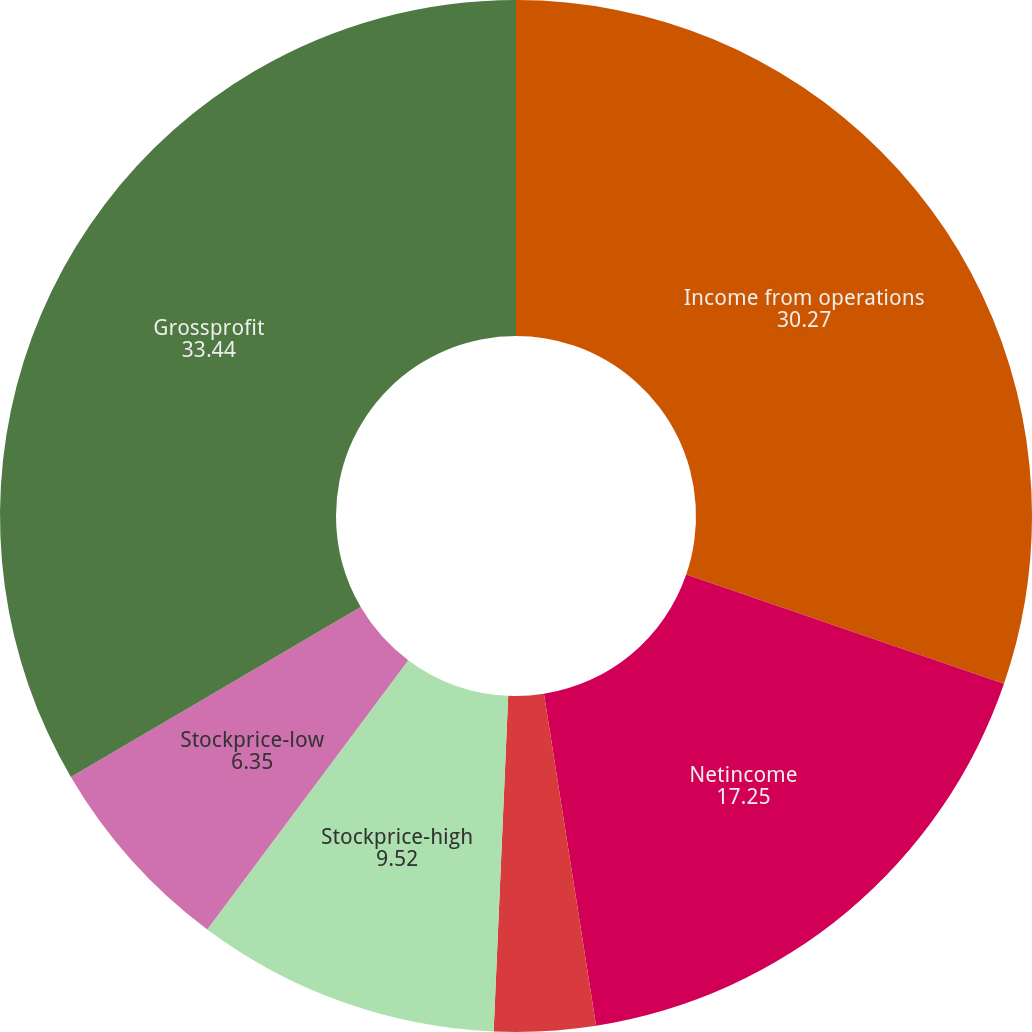Convert chart. <chart><loc_0><loc_0><loc_500><loc_500><pie_chart><fcel>Income from operations<fcel>Netincome<fcel>Basicearningsper share<fcel>Diluted earnings per share<fcel>Stockprice-high<fcel>Stockprice-low<fcel>Grossprofit<nl><fcel>30.27%<fcel>17.25%<fcel>0.0%<fcel>3.17%<fcel>9.52%<fcel>6.35%<fcel>33.44%<nl></chart> 